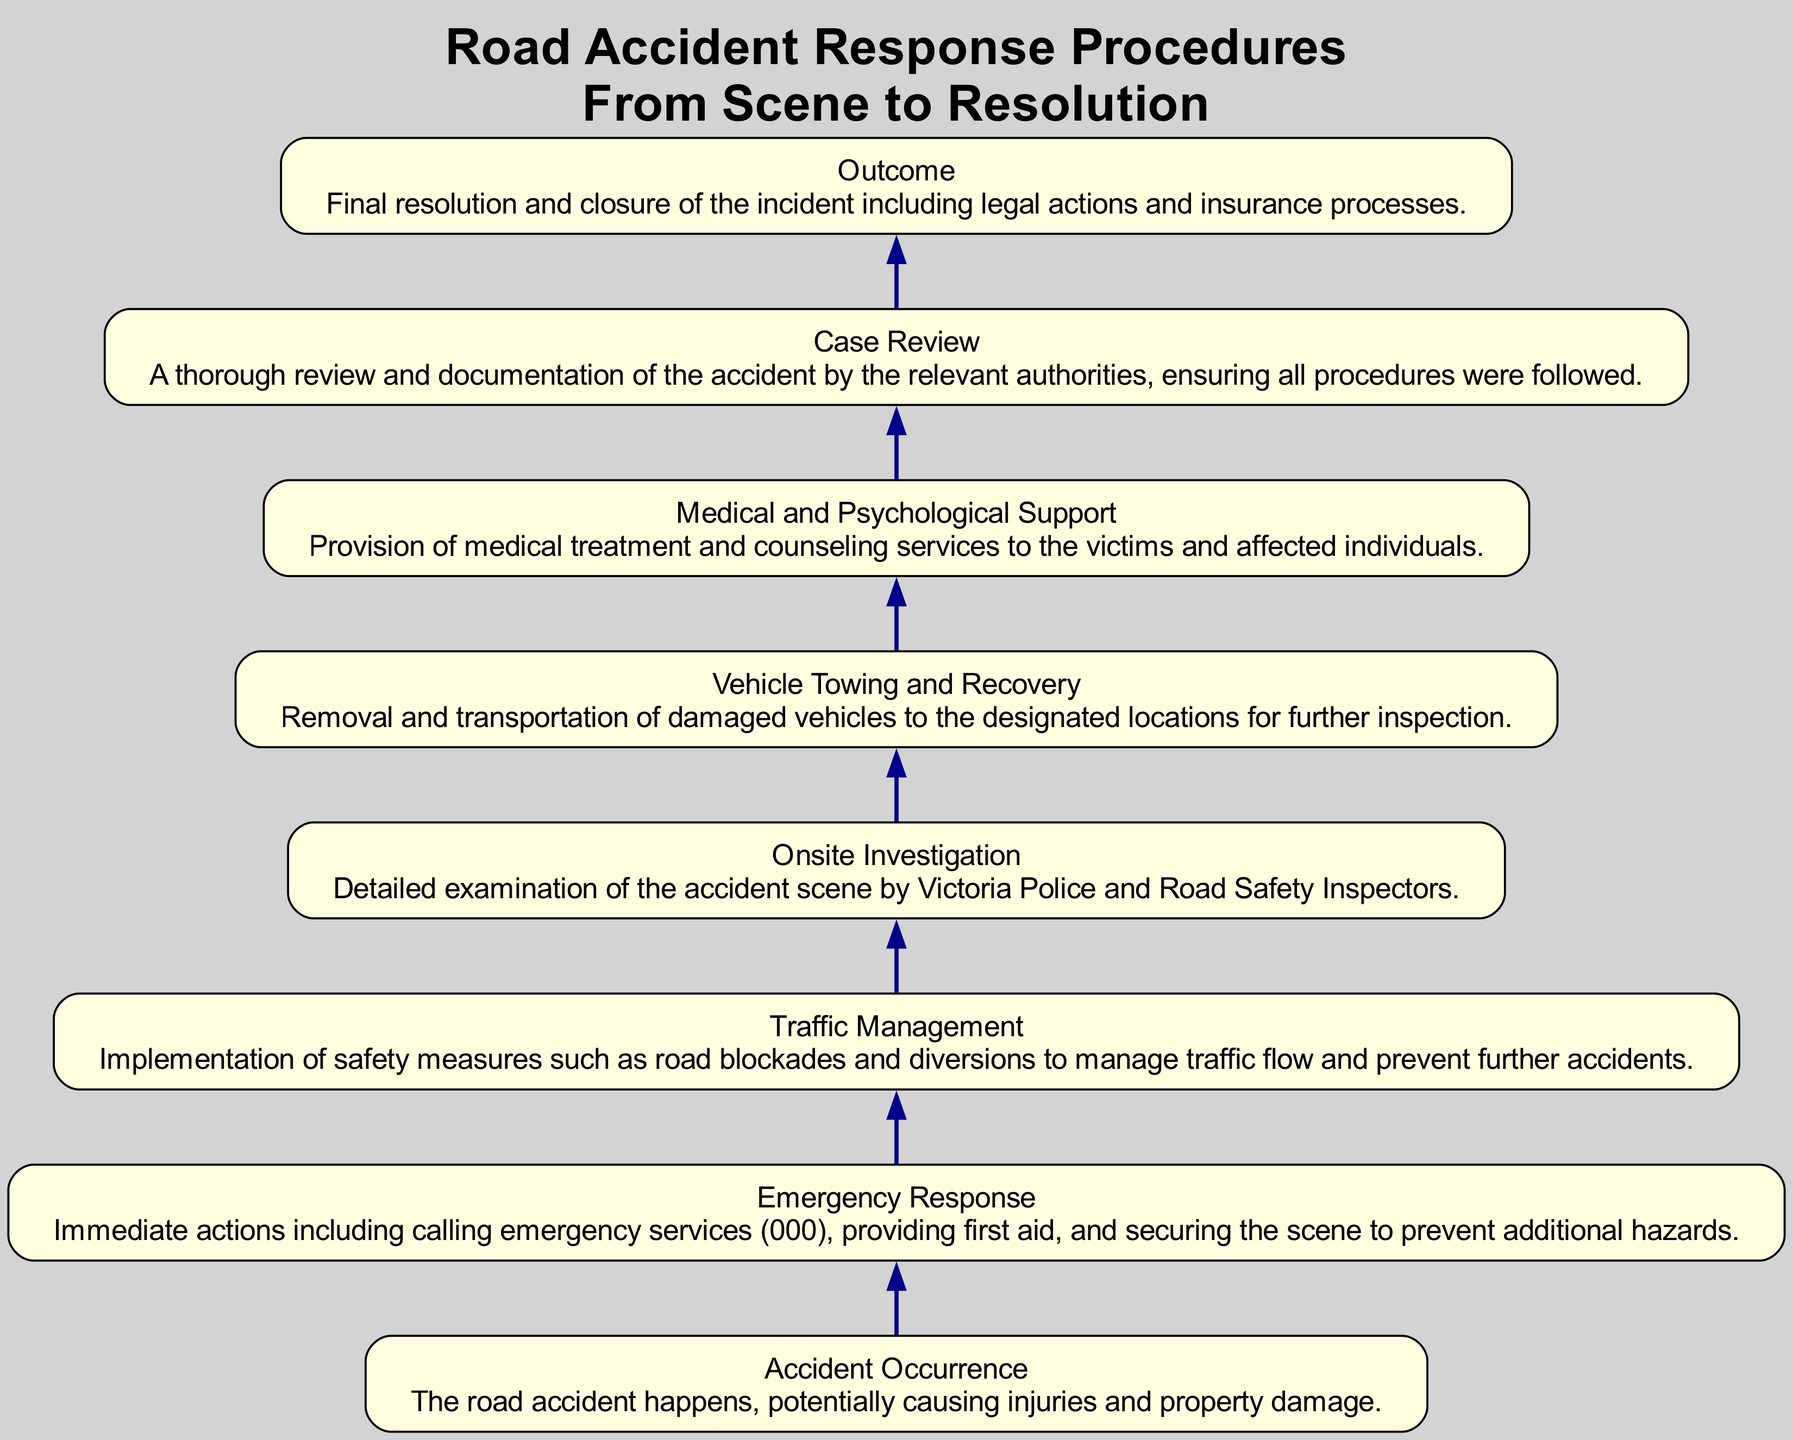What is the final outcome of the procedures? The outcome is described as the final resolution and closure of the incident. This step includes legal actions and insurance processes, which are the last phase in the response procedure.
Answer: Final resolution and closure of the incident including legal actions and insurance processes How many nodes are in the diagram? The diagram contains eight nodes, each representing a step in the road accident response procedures, starting from the accident occurrence to the final outcome.
Answer: Eight What happens immediately after the accident occurs? After the accident occurs, the immediate response involves emergency actions such as calling emergency services, providing first aid, and securing the scene to prevent hazards. This is the first action taken following the accident.
Answer: Immediate actions including calling emergency services, providing first aid, and securing the scene Which node comes after Vehicle Towing and Recovery? Following the Vehicle Towing and Recovery node is the Case Review node. This means that once vehicles are towed, a thorough case review and documentation of the accident is conducted by authorities.
Answer: Case Review What is the main purpose of Traffic Management? Traffic Management involves implementing safety measures like road blockades and diversions to control the flow of traffic and prevent additional accidents. This step is crucial to ensure the safety of all involved.
Answer: Implementation of safety measures such as road blockades and diversions to manage traffic flow and prevent further accidents Which step involves the investigation of the accident scene? The Onsite Investigation step involves the detailed examination of the accident scene. This is done by relevant authorities such as Victoria Police and Road Safety Inspectors to gather evidence and determine the circumstances surrounding the incident.
Answer: Detailed examination of the accident scene by Victoria Police and Road Safety Inspectors How does Medical and Psychological Support relate to the incident? Medical and Psychological Support is provided as a subsequent step that ensures victims and affected individuals receive necessary medical treatment and counseling following the accident. This highlights the ongoing care necessary after the incident.
Answer: Provision of medical treatment and counseling services to the victims and affected individuals What is the first action taken after a road accident occurs in the diagram’s flow? The first action taken is Emergency Response, which includes calling emergency services and providing immediate first aid. This step is crucial for ensuring the safety of those involved.
Answer: Immediate actions including calling emergency services (000), providing first aid, and securing the scene 